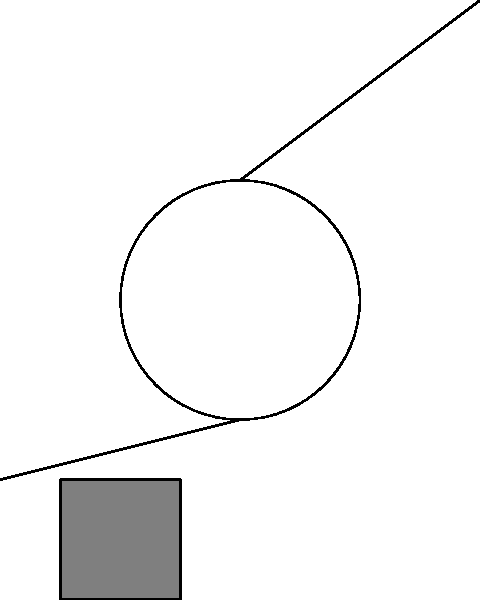As a parent of an autistic child, you're working on making your home more accessible. You need to lift a heavy box of sensory toys to a higher shelf. How does the simple pulley system shown in the diagram make it easier to lift the weight compared to lifting it directly? Let's break down how a simple pulley system works:

1. Force distribution: The pulley changes the direction of the force applied, allowing you to pull down instead of lifting up.

2. Mechanical advantage: In this system, the force is distributed over a longer distance. As you pull the rope, it travels twice the distance that the weight moves.

3. Work principle: The work done (Force × Distance) remains the same, but the force required is reduced.

4. Force reduction: The pulley effectively cuts the required force in half. If the weight is 100 N, you only need to apply about 50 N of force (neglecting friction).

5. Gravity assistance: By pulling downward, you can use your body weight to assist in the lifting process, which can be especially helpful for individuals with limited upper body strength.

6. Controlled movement: The pulley system allows for smoother, more controlled lifting, which can be beneficial when handling delicate or valuable items.

7. Safety: By reducing the force needed and allowing for better control, the pulley system enhances safety during lifting tasks.

For a parent managing a household with special needs, this system can make daily tasks more manageable and reduce the risk of strain or injury.
Answer: The pulley system reduces the required force by half and allows for downward pulling, making lifting easier and safer. 